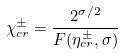Convert formula to latex. <formula><loc_0><loc_0><loc_500><loc_500>\chi ^ { \pm } _ { c r } = \frac { 2 ^ { \sigma / 2 } } { F ( \eta ^ { \pm } _ { c r } , \sigma ) }</formula> 